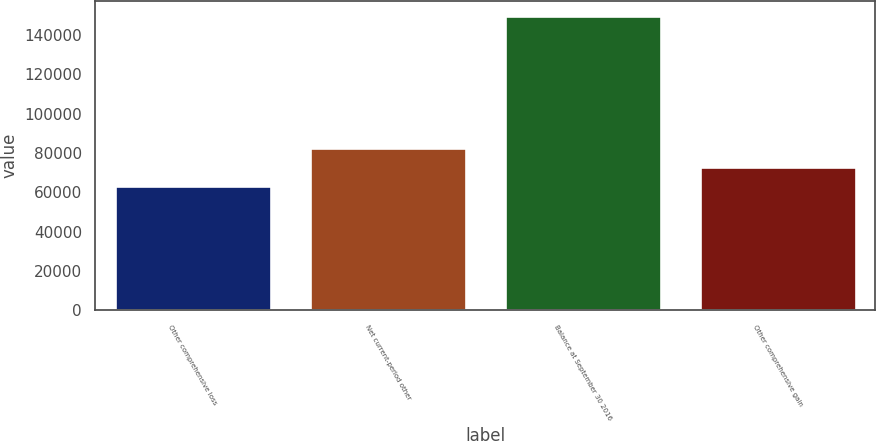<chart> <loc_0><loc_0><loc_500><loc_500><bar_chart><fcel>Other comprehensive loss<fcel>Net current-period other<fcel>Balance at September 30 2016<fcel>Other comprehensive gain<nl><fcel>63378.9<fcel>82580.7<fcel>149787<fcel>72979.8<nl></chart> 